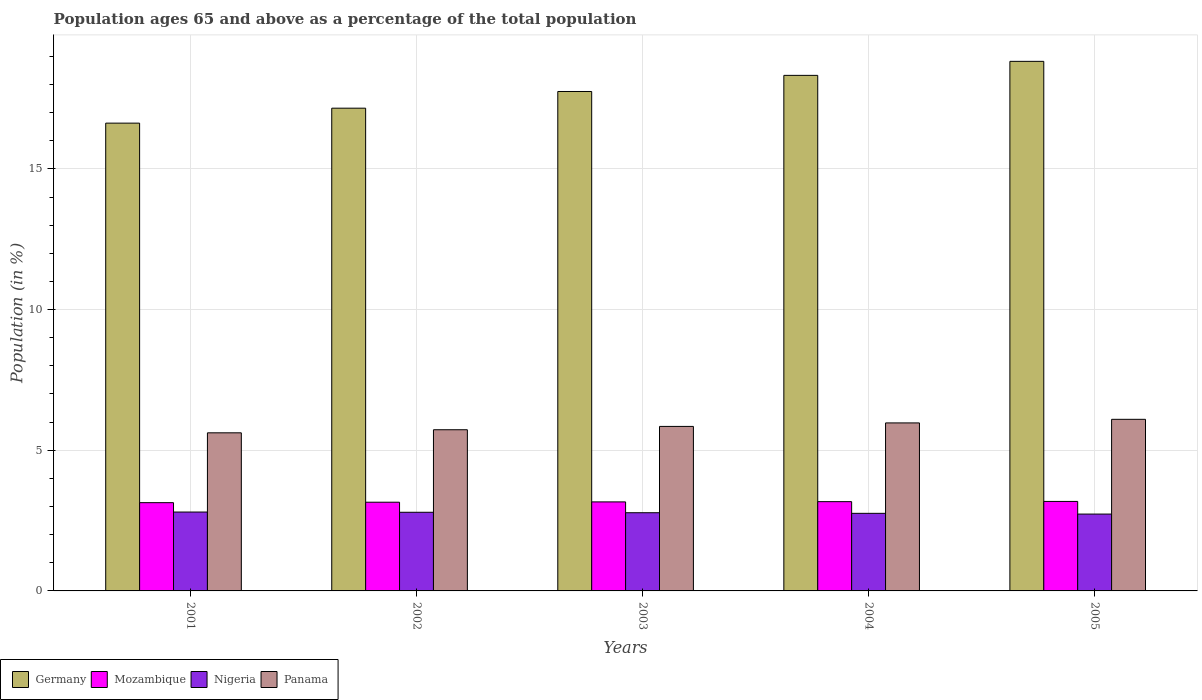How many different coloured bars are there?
Make the answer very short. 4. How many groups of bars are there?
Provide a succinct answer. 5. Are the number of bars on each tick of the X-axis equal?
Give a very brief answer. Yes. What is the label of the 5th group of bars from the left?
Provide a short and direct response. 2005. In how many cases, is the number of bars for a given year not equal to the number of legend labels?
Offer a terse response. 0. What is the percentage of the population ages 65 and above in Germany in 2004?
Offer a terse response. 18.32. Across all years, what is the maximum percentage of the population ages 65 and above in Panama?
Your response must be concise. 6.1. Across all years, what is the minimum percentage of the population ages 65 and above in Germany?
Keep it short and to the point. 16.63. In which year was the percentage of the population ages 65 and above in Panama minimum?
Keep it short and to the point. 2001. What is the total percentage of the population ages 65 and above in Mozambique in the graph?
Your response must be concise. 15.81. What is the difference between the percentage of the population ages 65 and above in Germany in 2003 and that in 2005?
Your answer should be compact. -1.07. What is the difference between the percentage of the population ages 65 and above in Mozambique in 2001 and the percentage of the population ages 65 and above in Panama in 2004?
Provide a short and direct response. -2.83. What is the average percentage of the population ages 65 and above in Panama per year?
Provide a succinct answer. 5.85. In the year 2003, what is the difference between the percentage of the population ages 65 and above in Panama and percentage of the population ages 65 and above in Mozambique?
Your response must be concise. 2.68. What is the ratio of the percentage of the population ages 65 and above in Germany in 2001 to that in 2003?
Ensure brevity in your answer.  0.94. Is the percentage of the population ages 65 and above in Germany in 2002 less than that in 2003?
Offer a very short reply. Yes. Is the difference between the percentage of the population ages 65 and above in Panama in 2001 and 2005 greater than the difference between the percentage of the population ages 65 and above in Mozambique in 2001 and 2005?
Provide a succinct answer. No. What is the difference between the highest and the second highest percentage of the population ages 65 and above in Germany?
Your response must be concise. 0.5. What is the difference between the highest and the lowest percentage of the population ages 65 and above in Germany?
Your response must be concise. 2.2. What does the 3rd bar from the left in 2003 represents?
Provide a succinct answer. Nigeria. Are all the bars in the graph horizontal?
Your answer should be very brief. No. How many years are there in the graph?
Your answer should be very brief. 5. Are the values on the major ticks of Y-axis written in scientific E-notation?
Give a very brief answer. No. Where does the legend appear in the graph?
Provide a short and direct response. Bottom left. How many legend labels are there?
Your response must be concise. 4. How are the legend labels stacked?
Make the answer very short. Horizontal. What is the title of the graph?
Your answer should be compact. Population ages 65 and above as a percentage of the total population. Does "Senegal" appear as one of the legend labels in the graph?
Provide a short and direct response. No. What is the label or title of the Y-axis?
Offer a very short reply. Population (in %). What is the Population (in %) of Germany in 2001?
Your answer should be very brief. 16.63. What is the Population (in %) of Mozambique in 2001?
Offer a terse response. 3.14. What is the Population (in %) of Nigeria in 2001?
Give a very brief answer. 2.8. What is the Population (in %) in Panama in 2001?
Provide a succinct answer. 5.62. What is the Population (in %) in Germany in 2002?
Provide a short and direct response. 17.16. What is the Population (in %) in Mozambique in 2002?
Your answer should be compact. 3.15. What is the Population (in %) of Nigeria in 2002?
Give a very brief answer. 2.8. What is the Population (in %) of Panama in 2002?
Make the answer very short. 5.73. What is the Population (in %) in Germany in 2003?
Provide a short and direct response. 17.75. What is the Population (in %) of Mozambique in 2003?
Your response must be concise. 3.16. What is the Population (in %) of Nigeria in 2003?
Offer a terse response. 2.78. What is the Population (in %) of Panama in 2003?
Your answer should be very brief. 5.85. What is the Population (in %) of Germany in 2004?
Your answer should be compact. 18.32. What is the Population (in %) of Mozambique in 2004?
Your answer should be compact. 3.17. What is the Population (in %) of Nigeria in 2004?
Provide a succinct answer. 2.76. What is the Population (in %) in Panama in 2004?
Offer a terse response. 5.97. What is the Population (in %) of Germany in 2005?
Make the answer very short. 18.82. What is the Population (in %) of Mozambique in 2005?
Give a very brief answer. 3.18. What is the Population (in %) of Nigeria in 2005?
Your response must be concise. 2.73. What is the Population (in %) of Panama in 2005?
Provide a short and direct response. 6.1. Across all years, what is the maximum Population (in %) of Germany?
Your answer should be very brief. 18.82. Across all years, what is the maximum Population (in %) in Mozambique?
Provide a succinct answer. 3.18. Across all years, what is the maximum Population (in %) of Nigeria?
Offer a terse response. 2.8. Across all years, what is the maximum Population (in %) of Panama?
Ensure brevity in your answer.  6.1. Across all years, what is the minimum Population (in %) of Germany?
Your response must be concise. 16.63. Across all years, what is the minimum Population (in %) in Mozambique?
Offer a terse response. 3.14. Across all years, what is the minimum Population (in %) of Nigeria?
Ensure brevity in your answer.  2.73. Across all years, what is the minimum Population (in %) in Panama?
Your answer should be compact. 5.62. What is the total Population (in %) in Germany in the graph?
Make the answer very short. 88.69. What is the total Population (in %) of Mozambique in the graph?
Make the answer very short. 15.81. What is the total Population (in %) in Nigeria in the graph?
Offer a terse response. 13.87. What is the total Population (in %) of Panama in the graph?
Offer a very short reply. 29.27. What is the difference between the Population (in %) in Germany in 2001 and that in 2002?
Give a very brief answer. -0.53. What is the difference between the Population (in %) in Mozambique in 2001 and that in 2002?
Your answer should be compact. -0.02. What is the difference between the Population (in %) of Nigeria in 2001 and that in 2002?
Your answer should be compact. 0.01. What is the difference between the Population (in %) of Panama in 2001 and that in 2002?
Your response must be concise. -0.11. What is the difference between the Population (in %) of Germany in 2001 and that in 2003?
Your answer should be very brief. -1.12. What is the difference between the Population (in %) in Mozambique in 2001 and that in 2003?
Give a very brief answer. -0.03. What is the difference between the Population (in %) of Nigeria in 2001 and that in 2003?
Make the answer very short. 0.02. What is the difference between the Population (in %) of Panama in 2001 and that in 2003?
Keep it short and to the point. -0.23. What is the difference between the Population (in %) of Germany in 2001 and that in 2004?
Provide a short and direct response. -1.7. What is the difference between the Population (in %) of Mozambique in 2001 and that in 2004?
Ensure brevity in your answer.  -0.04. What is the difference between the Population (in %) in Nigeria in 2001 and that in 2004?
Offer a terse response. 0.05. What is the difference between the Population (in %) in Panama in 2001 and that in 2004?
Provide a short and direct response. -0.35. What is the difference between the Population (in %) in Germany in 2001 and that in 2005?
Provide a short and direct response. -2.2. What is the difference between the Population (in %) in Mozambique in 2001 and that in 2005?
Offer a very short reply. -0.04. What is the difference between the Population (in %) in Nigeria in 2001 and that in 2005?
Make the answer very short. 0.07. What is the difference between the Population (in %) in Panama in 2001 and that in 2005?
Give a very brief answer. -0.48. What is the difference between the Population (in %) in Germany in 2002 and that in 2003?
Keep it short and to the point. -0.59. What is the difference between the Population (in %) of Mozambique in 2002 and that in 2003?
Ensure brevity in your answer.  -0.01. What is the difference between the Population (in %) of Nigeria in 2002 and that in 2003?
Your response must be concise. 0.02. What is the difference between the Population (in %) in Panama in 2002 and that in 2003?
Offer a very short reply. -0.12. What is the difference between the Population (in %) in Germany in 2002 and that in 2004?
Your answer should be very brief. -1.17. What is the difference between the Population (in %) in Mozambique in 2002 and that in 2004?
Your answer should be compact. -0.02. What is the difference between the Population (in %) in Nigeria in 2002 and that in 2004?
Your response must be concise. 0.04. What is the difference between the Population (in %) in Panama in 2002 and that in 2004?
Ensure brevity in your answer.  -0.24. What is the difference between the Population (in %) in Germany in 2002 and that in 2005?
Make the answer very short. -1.66. What is the difference between the Population (in %) of Mozambique in 2002 and that in 2005?
Offer a terse response. -0.03. What is the difference between the Population (in %) in Nigeria in 2002 and that in 2005?
Your answer should be very brief. 0.06. What is the difference between the Population (in %) in Panama in 2002 and that in 2005?
Offer a very short reply. -0.37. What is the difference between the Population (in %) of Germany in 2003 and that in 2004?
Provide a succinct answer. -0.57. What is the difference between the Population (in %) of Mozambique in 2003 and that in 2004?
Offer a very short reply. -0.01. What is the difference between the Population (in %) of Nigeria in 2003 and that in 2004?
Ensure brevity in your answer.  0.02. What is the difference between the Population (in %) in Panama in 2003 and that in 2004?
Your response must be concise. -0.12. What is the difference between the Population (in %) in Germany in 2003 and that in 2005?
Provide a succinct answer. -1.07. What is the difference between the Population (in %) in Mozambique in 2003 and that in 2005?
Give a very brief answer. -0.02. What is the difference between the Population (in %) of Nigeria in 2003 and that in 2005?
Your answer should be very brief. 0.05. What is the difference between the Population (in %) in Panama in 2003 and that in 2005?
Your answer should be compact. -0.25. What is the difference between the Population (in %) in Germany in 2004 and that in 2005?
Your answer should be compact. -0.5. What is the difference between the Population (in %) in Mozambique in 2004 and that in 2005?
Make the answer very short. -0.01. What is the difference between the Population (in %) of Nigeria in 2004 and that in 2005?
Provide a short and direct response. 0.03. What is the difference between the Population (in %) of Panama in 2004 and that in 2005?
Make the answer very short. -0.13. What is the difference between the Population (in %) in Germany in 2001 and the Population (in %) in Mozambique in 2002?
Keep it short and to the point. 13.47. What is the difference between the Population (in %) in Germany in 2001 and the Population (in %) in Nigeria in 2002?
Give a very brief answer. 13.83. What is the difference between the Population (in %) of Germany in 2001 and the Population (in %) of Panama in 2002?
Your answer should be very brief. 10.9. What is the difference between the Population (in %) of Mozambique in 2001 and the Population (in %) of Nigeria in 2002?
Offer a terse response. 0.34. What is the difference between the Population (in %) in Mozambique in 2001 and the Population (in %) in Panama in 2002?
Make the answer very short. -2.59. What is the difference between the Population (in %) of Nigeria in 2001 and the Population (in %) of Panama in 2002?
Your response must be concise. -2.93. What is the difference between the Population (in %) of Germany in 2001 and the Population (in %) of Mozambique in 2003?
Ensure brevity in your answer.  13.46. What is the difference between the Population (in %) of Germany in 2001 and the Population (in %) of Nigeria in 2003?
Keep it short and to the point. 13.85. What is the difference between the Population (in %) in Germany in 2001 and the Population (in %) in Panama in 2003?
Give a very brief answer. 10.78. What is the difference between the Population (in %) in Mozambique in 2001 and the Population (in %) in Nigeria in 2003?
Offer a very short reply. 0.36. What is the difference between the Population (in %) in Mozambique in 2001 and the Population (in %) in Panama in 2003?
Provide a succinct answer. -2.71. What is the difference between the Population (in %) of Nigeria in 2001 and the Population (in %) of Panama in 2003?
Offer a terse response. -3.04. What is the difference between the Population (in %) of Germany in 2001 and the Population (in %) of Mozambique in 2004?
Make the answer very short. 13.45. What is the difference between the Population (in %) of Germany in 2001 and the Population (in %) of Nigeria in 2004?
Give a very brief answer. 13.87. What is the difference between the Population (in %) in Germany in 2001 and the Population (in %) in Panama in 2004?
Offer a very short reply. 10.66. What is the difference between the Population (in %) in Mozambique in 2001 and the Population (in %) in Nigeria in 2004?
Offer a very short reply. 0.38. What is the difference between the Population (in %) in Mozambique in 2001 and the Population (in %) in Panama in 2004?
Your answer should be very brief. -2.83. What is the difference between the Population (in %) in Nigeria in 2001 and the Population (in %) in Panama in 2004?
Give a very brief answer. -3.17. What is the difference between the Population (in %) of Germany in 2001 and the Population (in %) of Mozambique in 2005?
Your answer should be very brief. 13.45. What is the difference between the Population (in %) of Germany in 2001 and the Population (in %) of Nigeria in 2005?
Make the answer very short. 13.9. What is the difference between the Population (in %) of Germany in 2001 and the Population (in %) of Panama in 2005?
Ensure brevity in your answer.  10.53. What is the difference between the Population (in %) in Mozambique in 2001 and the Population (in %) in Nigeria in 2005?
Offer a terse response. 0.41. What is the difference between the Population (in %) in Mozambique in 2001 and the Population (in %) in Panama in 2005?
Keep it short and to the point. -2.96. What is the difference between the Population (in %) of Nigeria in 2001 and the Population (in %) of Panama in 2005?
Keep it short and to the point. -3.3. What is the difference between the Population (in %) of Germany in 2002 and the Population (in %) of Mozambique in 2003?
Ensure brevity in your answer.  13.99. What is the difference between the Population (in %) in Germany in 2002 and the Population (in %) in Nigeria in 2003?
Offer a very short reply. 14.38. What is the difference between the Population (in %) in Germany in 2002 and the Population (in %) in Panama in 2003?
Provide a short and direct response. 11.31. What is the difference between the Population (in %) in Mozambique in 2002 and the Population (in %) in Nigeria in 2003?
Your response must be concise. 0.37. What is the difference between the Population (in %) of Mozambique in 2002 and the Population (in %) of Panama in 2003?
Offer a terse response. -2.69. What is the difference between the Population (in %) in Nigeria in 2002 and the Population (in %) in Panama in 2003?
Your response must be concise. -3.05. What is the difference between the Population (in %) in Germany in 2002 and the Population (in %) in Mozambique in 2004?
Keep it short and to the point. 13.99. What is the difference between the Population (in %) of Germany in 2002 and the Population (in %) of Nigeria in 2004?
Make the answer very short. 14.4. What is the difference between the Population (in %) in Germany in 2002 and the Population (in %) in Panama in 2004?
Ensure brevity in your answer.  11.19. What is the difference between the Population (in %) in Mozambique in 2002 and the Population (in %) in Nigeria in 2004?
Give a very brief answer. 0.4. What is the difference between the Population (in %) of Mozambique in 2002 and the Population (in %) of Panama in 2004?
Your answer should be compact. -2.82. What is the difference between the Population (in %) of Nigeria in 2002 and the Population (in %) of Panama in 2004?
Give a very brief answer. -3.18. What is the difference between the Population (in %) of Germany in 2002 and the Population (in %) of Mozambique in 2005?
Provide a short and direct response. 13.98. What is the difference between the Population (in %) in Germany in 2002 and the Population (in %) in Nigeria in 2005?
Make the answer very short. 14.43. What is the difference between the Population (in %) in Germany in 2002 and the Population (in %) in Panama in 2005?
Provide a succinct answer. 11.06. What is the difference between the Population (in %) in Mozambique in 2002 and the Population (in %) in Nigeria in 2005?
Give a very brief answer. 0.42. What is the difference between the Population (in %) in Mozambique in 2002 and the Population (in %) in Panama in 2005?
Provide a short and direct response. -2.95. What is the difference between the Population (in %) in Nigeria in 2002 and the Population (in %) in Panama in 2005?
Provide a short and direct response. -3.3. What is the difference between the Population (in %) in Germany in 2003 and the Population (in %) in Mozambique in 2004?
Ensure brevity in your answer.  14.58. What is the difference between the Population (in %) in Germany in 2003 and the Population (in %) in Nigeria in 2004?
Your response must be concise. 14.99. What is the difference between the Population (in %) of Germany in 2003 and the Population (in %) of Panama in 2004?
Provide a short and direct response. 11.78. What is the difference between the Population (in %) in Mozambique in 2003 and the Population (in %) in Nigeria in 2004?
Provide a short and direct response. 0.41. What is the difference between the Population (in %) in Mozambique in 2003 and the Population (in %) in Panama in 2004?
Your answer should be very brief. -2.81. What is the difference between the Population (in %) of Nigeria in 2003 and the Population (in %) of Panama in 2004?
Make the answer very short. -3.19. What is the difference between the Population (in %) of Germany in 2003 and the Population (in %) of Mozambique in 2005?
Your answer should be very brief. 14.57. What is the difference between the Population (in %) of Germany in 2003 and the Population (in %) of Nigeria in 2005?
Provide a short and direct response. 15.02. What is the difference between the Population (in %) in Germany in 2003 and the Population (in %) in Panama in 2005?
Provide a short and direct response. 11.65. What is the difference between the Population (in %) in Mozambique in 2003 and the Population (in %) in Nigeria in 2005?
Your answer should be compact. 0.43. What is the difference between the Population (in %) in Mozambique in 2003 and the Population (in %) in Panama in 2005?
Keep it short and to the point. -2.93. What is the difference between the Population (in %) in Nigeria in 2003 and the Population (in %) in Panama in 2005?
Make the answer very short. -3.32. What is the difference between the Population (in %) of Germany in 2004 and the Population (in %) of Mozambique in 2005?
Your answer should be very brief. 15.14. What is the difference between the Population (in %) in Germany in 2004 and the Population (in %) in Nigeria in 2005?
Provide a short and direct response. 15.59. What is the difference between the Population (in %) in Germany in 2004 and the Population (in %) in Panama in 2005?
Offer a very short reply. 12.23. What is the difference between the Population (in %) in Mozambique in 2004 and the Population (in %) in Nigeria in 2005?
Offer a terse response. 0.44. What is the difference between the Population (in %) of Mozambique in 2004 and the Population (in %) of Panama in 2005?
Your response must be concise. -2.93. What is the difference between the Population (in %) of Nigeria in 2004 and the Population (in %) of Panama in 2005?
Make the answer very short. -3.34. What is the average Population (in %) in Germany per year?
Provide a succinct answer. 17.74. What is the average Population (in %) of Mozambique per year?
Offer a terse response. 3.16. What is the average Population (in %) of Nigeria per year?
Offer a terse response. 2.77. What is the average Population (in %) in Panama per year?
Your response must be concise. 5.85. In the year 2001, what is the difference between the Population (in %) in Germany and Population (in %) in Mozambique?
Provide a short and direct response. 13.49. In the year 2001, what is the difference between the Population (in %) of Germany and Population (in %) of Nigeria?
Provide a succinct answer. 13.82. In the year 2001, what is the difference between the Population (in %) of Germany and Population (in %) of Panama?
Offer a terse response. 11.01. In the year 2001, what is the difference between the Population (in %) of Mozambique and Population (in %) of Nigeria?
Provide a succinct answer. 0.33. In the year 2001, what is the difference between the Population (in %) in Mozambique and Population (in %) in Panama?
Ensure brevity in your answer.  -2.48. In the year 2001, what is the difference between the Population (in %) of Nigeria and Population (in %) of Panama?
Provide a succinct answer. -2.82. In the year 2002, what is the difference between the Population (in %) in Germany and Population (in %) in Mozambique?
Your answer should be very brief. 14.01. In the year 2002, what is the difference between the Population (in %) in Germany and Population (in %) in Nigeria?
Your answer should be compact. 14.36. In the year 2002, what is the difference between the Population (in %) of Germany and Population (in %) of Panama?
Your response must be concise. 11.43. In the year 2002, what is the difference between the Population (in %) in Mozambique and Population (in %) in Nigeria?
Provide a short and direct response. 0.36. In the year 2002, what is the difference between the Population (in %) of Mozambique and Population (in %) of Panama?
Give a very brief answer. -2.58. In the year 2002, what is the difference between the Population (in %) of Nigeria and Population (in %) of Panama?
Your answer should be compact. -2.93. In the year 2003, what is the difference between the Population (in %) in Germany and Population (in %) in Mozambique?
Ensure brevity in your answer.  14.59. In the year 2003, what is the difference between the Population (in %) of Germany and Population (in %) of Nigeria?
Offer a terse response. 14.97. In the year 2003, what is the difference between the Population (in %) of Germany and Population (in %) of Panama?
Give a very brief answer. 11.9. In the year 2003, what is the difference between the Population (in %) of Mozambique and Population (in %) of Nigeria?
Make the answer very short. 0.38. In the year 2003, what is the difference between the Population (in %) of Mozambique and Population (in %) of Panama?
Give a very brief answer. -2.68. In the year 2003, what is the difference between the Population (in %) of Nigeria and Population (in %) of Panama?
Make the answer very short. -3.07. In the year 2004, what is the difference between the Population (in %) of Germany and Population (in %) of Mozambique?
Your answer should be compact. 15.15. In the year 2004, what is the difference between the Population (in %) of Germany and Population (in %) of Nigeria?
Ensure brevity in your answer.  15.57. In the year 2004, what is the difference between the Population (in %) of Germany and Population (in %) of Panama?
Ensure brevity in your answer.  12.35. In the year 2004, what is the difference between the Population (in %) in Mozambique and Population (in %) in Nigeria?
Your response must be concise. 0.42. In the year 2004, what is the difference between the Population (in %) of Mozambique and Population (in %) of Panama?
Your response must be concise. -2.8. In the year 2004, what is the difference between the Population (in %) of Nigeria and Population (in %) of Panama?
Your response must be concise. -3.21. In the year 2005, what is the difference between the Population (in %) of Germany and Population (in %) of Mozambique?
Offer a very short reply. 15.64. In the year 2005, what is the difference between the Population (in %) of Germany and Population (in %) of Nigeria?
Provide a succinct answer. 16.09. In the year 2005, what is the difference between the Population (in %) in Germany and Population (in %) in Panama?
Provide a short and direct response. 12.72. In the year 2005, what is the difference between the Population (in %) of Mozambique and Population (in %) of Nigeria?
Your answer should be very brief. 0.45. In the year 2005, what is the difference between the Population (in %) of Mozambique and Population (in %) of Panama?
Ensure brevity in your answer.  -2.92. In the year 2005, what is the difference between the Population (in %) in Nigeria and Population (in %) in Panama?
Your answer should be very brief. -3.37. What is the ratio of the Population (in %) in Panama in 2001 to that in 2002?
Make the answer very short. 0.98. What is the ratio of the Population (in %) of Germany in 2001 to that in 2003?
Make the answer very short. 0.94. What is the ratio of the Population (in %) in Nigeria in 2001 to that in 2003?
Make the answer very short. 1.01. What is the ratio of the Population (in %) of Panama in 2001 to that in 2003?
Provide a succinct answer. 0.96. What is the ratio of the Population (in %) of Germany in 2001 to that in 2004?
Give a very brief answer. 0.91. What is the ratio of the Population (in %) of Nigeria in 2001 to that in 2004?
Keep it short and to the point. 1.02. What is the ratio of the Population (in %) in Panama in 2001 to that in 2004?
Keep it short and to the point. 0.94. What is the ratio of the Population (in %) in Germany in 2001 to that in 2005?
Your answer should be compact. 0.88. What is the ratio of the Population (in %) of Mozambique in 2001 to that in 2005?
Offer a terse response. 0.99. What is the ratio of the Population (in %) in Nigeria in 2001 to that in 2005?
Your answer should be very brief. 1.03. What is the ratio of the Population (in %) of Panama in 2001 to that in 2005?
Make the answer very short. 0.92. What is the ratio of the Population (in %) in Germany in 2002 to that in 2003?
Provide a succinct answer. 0.97. What is the ratio of the Population (in %) of Panama in 2002 to that in 2003?
Make the answer very short. 0.98. What is the ratio of the Population (in %) in Germany in 2002 to that in 2004?
Provide a succinct answer. 0.94. What is the ratio of the Population (in %) of Nigeria in 2002 to that in 2004?
Your response must be concise. 1.01. What is the ratio of the Population (in %) in Panama in 2002 to that in 2004?
Provide a short and direct response. 0.96. What is the ratio of the Population (in %) of Germany in 2002 to that in 2005?
Keep it short and to the point. 0.91. What is the ratio of the Population (in %) in Nigeria in 2002 to that in 2005?
Offer a very short reply. 1.02. What is the ratio of the Population (in %) of Panama in 2002 to that in 2005?
Offer a terse response. 0.94. What is the ratio of the Population (in %) in Germany in 2003 to that in 2004?
Give a very brief answer. 0.97. What is the ratio of the Population (in %) of Nigeria in 2003 to that in 2004?
Offer a terse response. 1.01. What is the ratio of the Population (in %) in Panama in 2003 to that in 2004?
Offer a terse response. 0.98. What is the ratio of the Population (in %) of Germany in 2003 to that in 2005?
Make the answer very short. 0.94. What is the ratio of the Population (in %) in Nigeria in 2003 to that in 2005?
Make the answer very short. 1.02. What is the ratio of the Population (in %) of Panama in 2003 to that in 2005?
Offer a very short reply. 0.96. What is the ratio of the Population (in %) of Germany in 2004 to that in 2005?
Give a very brief answer. 0.97. What is the ratio of the Population (in %) in Mozambique in 2004 to that in 2005?
Your answer should be compact. 1. What is the ratio of the Population (in %) in Nigeria in 2004 to that in 2005?
Offer a terse response. 1.01. What is the ratio of the Population (in %) of Panama in 2004 to that in 2005?
Make the answer very short. 0.98. What is the difference between the highest and the second highest Population (in %) of Germany?
Your answer should be compact. 0.5. What is the difference between the highest and the second highest Population (in %) in Mozambique?
Ensure brevity in your answer.  0.01. What is the difference between the highest and the second highest Population (in %) of Nigeria?
Offer a very short reply. 0.01. What is the difference between the highest and the second highest Population (in %) in Panama?
Your answer should be compact. 0.13. What is the difference between the highest and the lowest Population (in %) of Germany?
Provide a short and direct response. 2.2. What is the difference between the highest and the lowest Population (in %) in Mozambique?
Offer a terse response. 0.04. What is the difference between the highest and the lowest Population (in %) of Nigeria?
Provide a short and direct response. 0.07. What is the difference between the highest and the lowest Population (in %) of Panama?
Provide a succinct answer. 0.48. 